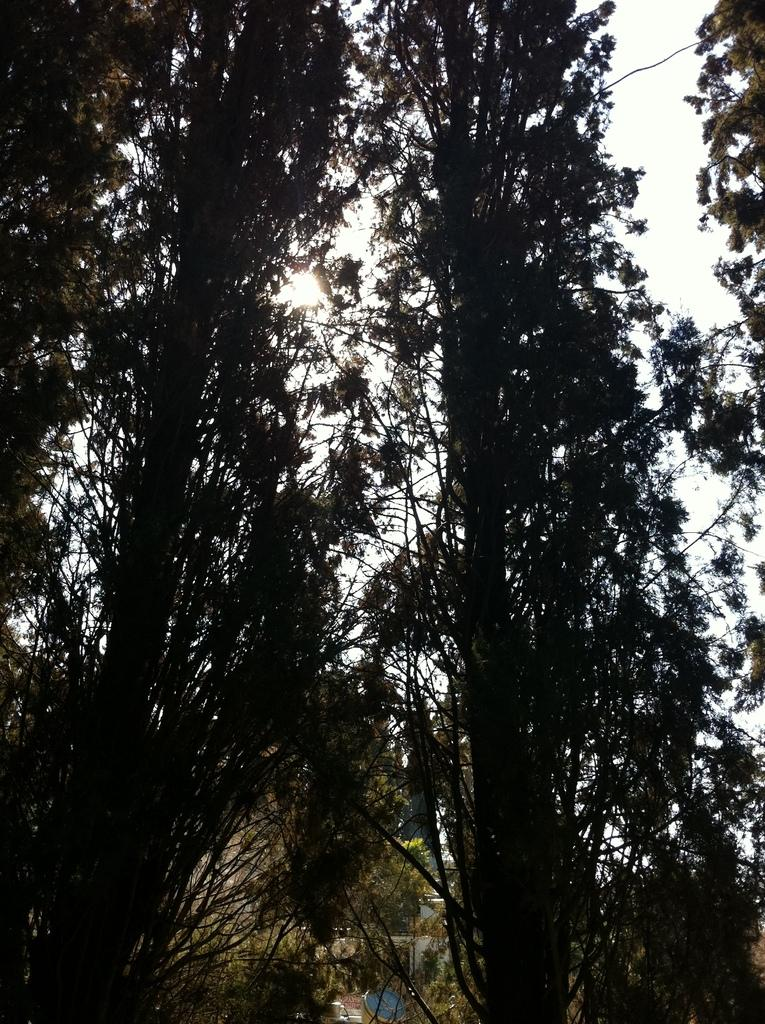What type of natural elements can be seen in the image? There are trees in the image. What else is present in the image besides the trees? There are objects in the image. What can be seen in the distance in the image? The sky is visible in the background of the image. What type of books are being used to build the treehouse in the image? There is no treehouse or books present in the image. 